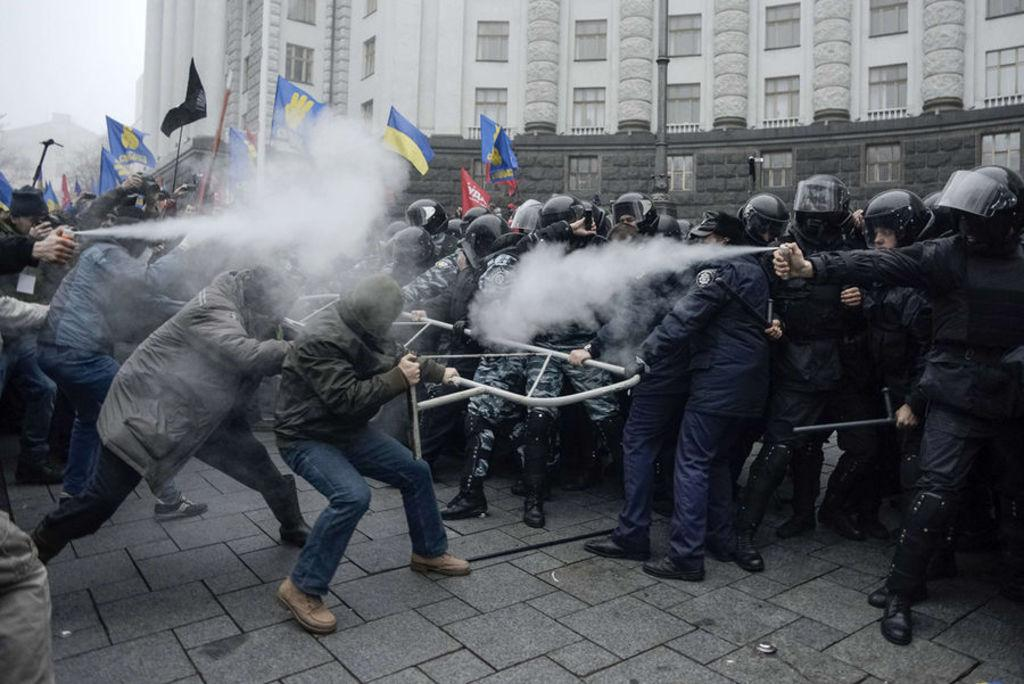What is located in the center of the image? There are soldiers, people, flags, a stick, and smoke in the center of the image. What can be found in the background of the image? There are buildings and trees in the background of the image. How many distinct objects can be seen in the center of the image? There are at least six distinct objects in the center of the image: soldiers, people, flags, a stick, smoke, and other objects. What type of beast can be seen working in the image? There is no beast present in the image, and no one is shown working. What type of pleasure can be seen in the image? There is no indication of pleasure in the image; it features soldiers, people, flags, a stick, smoke, and other objects in the center, with buildings and trees in the background. 